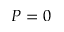Convert formula to latex. <formula><loc_0><loc_0><loc_500><loc_500>P = 0</formula> 